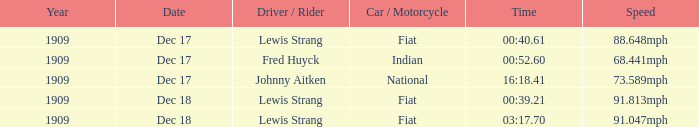What car/motorcycle goes 91.813mph? Fiat. 